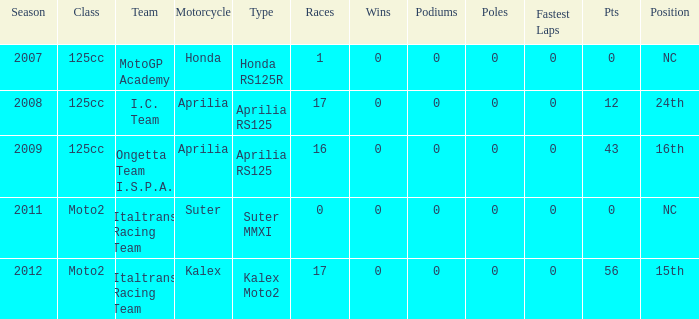How many fastest laps did I.C. Team have? 1.0. 